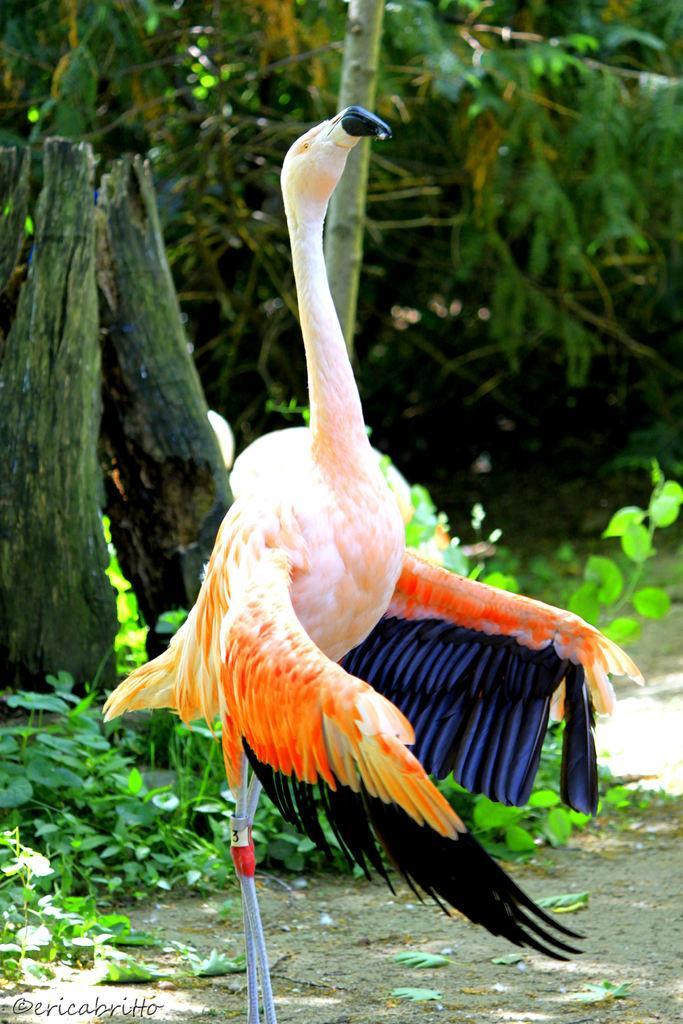Could you give a brief overview of what you see in this image? At the bottom of this image, there is a bird. In the background, there are trees and plants. 